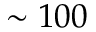Convert formula to latex. <formula><loc_0><loc_0><loc_500><loc_500>\sim 1 0 0</formula> 